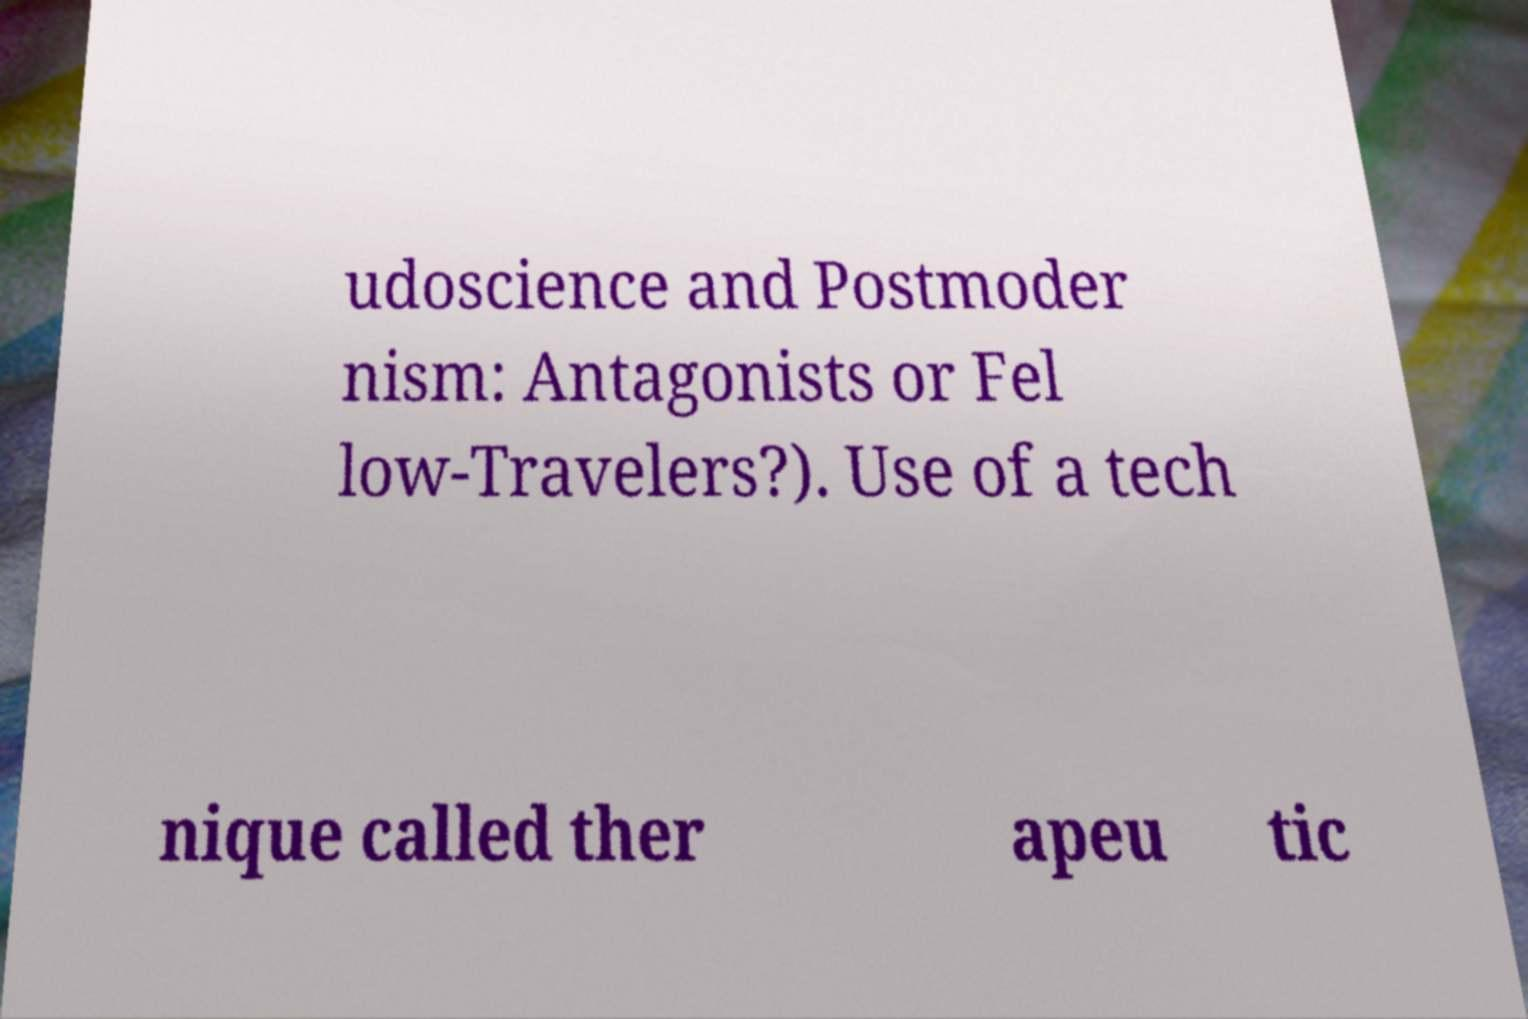Please identify and transcribe the text found in this image. udoscience and Postmoder nism: Antagonists or Fel low-Travelers?). Use of a tech nique called ther apeu tic 